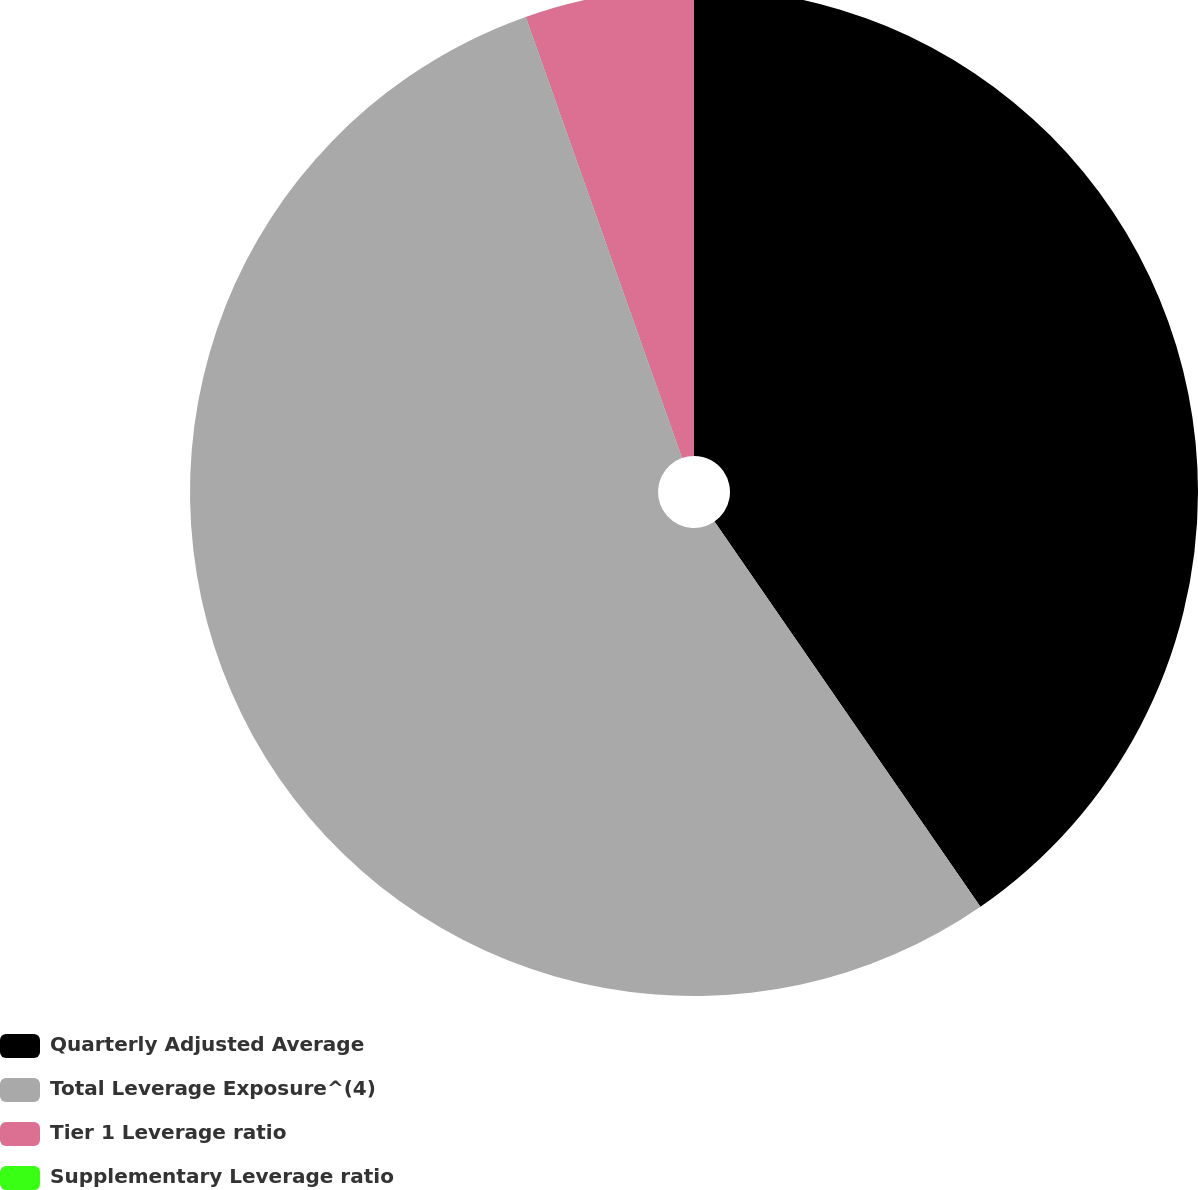Convert chart to OTSL. <chart><loc_0><loc_0><loc_500><loc_500><pie_chart><fcel>Quarterly Adjusted Average<fcel>Total Leverage Exposure^(4)<fcel>Tier 1 Leverage ratio<fcel>Supplementary Leverage ratio<nl><fcel>40.38%<fcel>54.2%<fcel>5.42%<fcel>0.0%<nl></chart> 